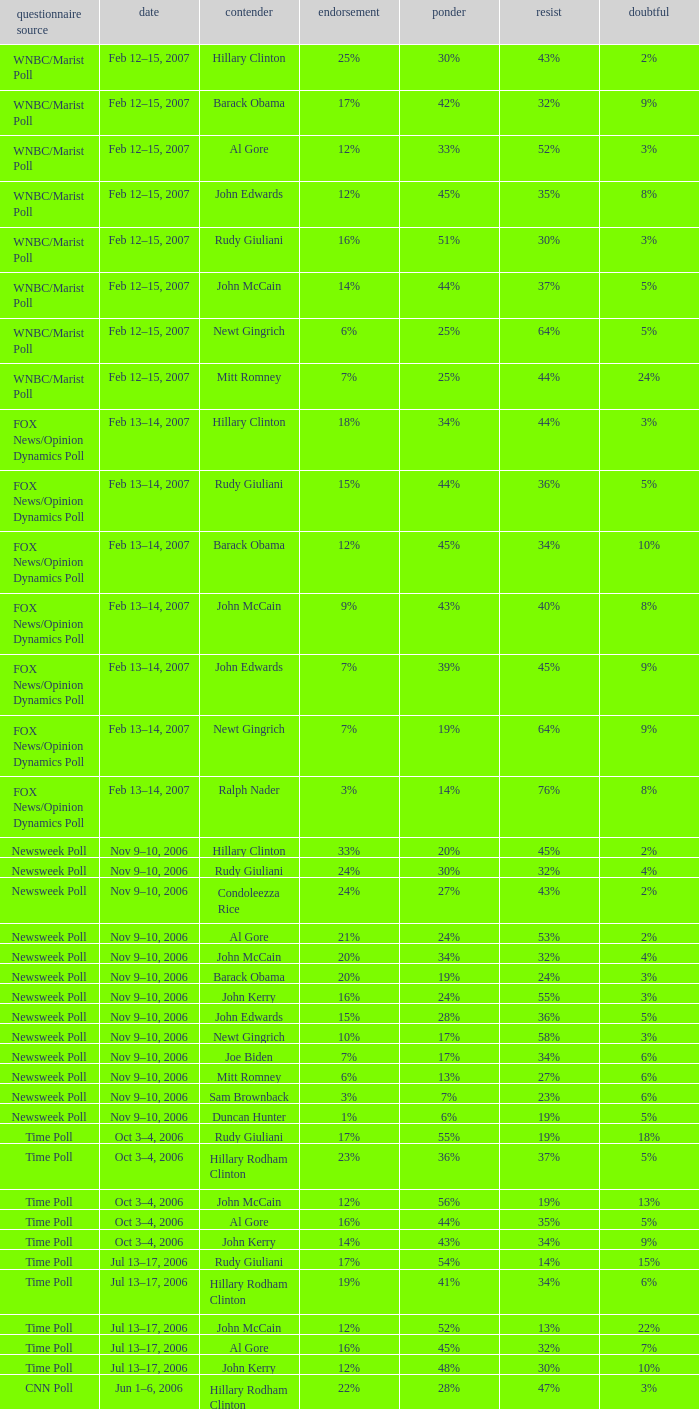Could you help me parse every detail presented in this table? {'header': ['questionnaire source', 'date', 'contender', 'endorsement', 'ponder', 'resist', 'doubtful'], 'rows': [['WNBC/Marist Poll', 'Feb 12–15, 2007', 'Hillary Clinton', '25%', '30%', '43%', '2%'], ['WNBC/Marist Poll', 'Feb 12–15, 2007', 'Barack Obama', '17%', '42%', '32%', '9%'], ['WNBC/Marist Poll', 'Feb 12–15, 2007', 'Al Gore', '12%', '33%', '52%', '3%'], ['WNBC/Marist Poll', 'Feb 12–15, 2007', 'John Edwards', '12%', '45%', '35%', '8%'], ['WNBC/Marist Poll', 'Feb 12–15, 2007', 'Rudy Giuliani', '16%', '51%', '30%', '3%'], ['WNBC/Marist Poll', 'Feb 12–15, 2007', 'John McCain', '14%', '44%', '37%', '5%'], ['WNBC/Marist Poll', 'Feb 12–15, 2007', 'Newt Gingrich', '6%', '25%', '64%', '5%'], ['WNBC/Marist Poll', 'Feb 12–15, 2007', 'Mitt Romney', '7%', '25%', '44%', '24%'], ['FOX News/Opinion Dynamics Poll', 'Feb 13–14, 2007', 'Hillary Clinton', '18%', '34%', '44%', '3%'], ['FOX News/Opinion Dynamics Poll', 'Feb 13–14, 2007', 'Rudy Giuliani', '15%', '44%', '36%', '5%'], ['FOX News/Opinion Dynamics Poll', 'Feb 13–14, 2007', 'Barack Obama', '12%', '45%', '34%', '10%'], ['FOX News/Opinion Dynamics Poll', 'Feb 13–14, 2007', 'John McCain', '9%', '43%', '40%', '8%'], ['FOX News/Opinion Dynamics Poll', 'Feb 13–14, 2007', 'John Edwards', '7%', '39%', '45%', '9%'], ['FOX News/Opinion Dynamics Poll', 'Feb 13–14, 2007', 'Newt Gingrich', '7%', '19%', '64%', '9%'], ['FOX News/Opinion Dynamics Poll', 'Feb 13–14, 2007', 'Ralph Nader', '3%', '14%', '76%', '8%'], ['Newsweek Poll', 'Nov 9–10, 2006', 'Hillary Clinton', '33%', '20%', '45%', '2%'], ['Newsweek Poll', 'Nov 9–10, 2006', 'Rudy Giuliani', '24%', '30%', '32%', '4%'], ['Newsweek Poll', 'Nov 9–10, 2006', 'Condoleezza Rice', '24%', '27%', '43%', '2%'], ['Newsweek Poll', 'Nov 9–10, 2006', 'Al Gore', '21%', '24%', '53%', '2%'], ['Newsweek Poll', 'Nov 9–10, 2006', 'John McCain', '20%', '34%', '32%', '4%'], ['Newsweek Poll', 'Nov 9–10, 2006', 'Barack Obama', '20%', '19%', '24%', '3%'], ['Newsweek Poll', 'Nov 9–10, 2006', 'John Kerry', '16%', '24%', '55%', '3%'], ['Newsweek Poll', 'Nov 9–10, 2006', 'John Edwards', '15%', '28%', '36%', '5%'], ['Newsweek Poll', 'Nov 9–10, 2006', 'Newt Gingrich', '10%', '17%', '58%', '3%'], ['Newsweek Poll', 'Nov 9–10, 2006', 'Joe Biden', '7%', '17%', '34%', '6%'], ['Newsweek Poll', 'Nov 9–10, 2006', 'Mitt Romney', '6%', '13%', '27%', '6%'], ['Newsweek Poll', 'Nov 9–10, 2006', 'Sam Brownback', '3%', '7%', '23%', '6%'], ['Newsweek Poll', 'Nov 9–10, 2006', 'Duncan Hunter', '1%', '6%', '19%', '5%'], ['Time Poll', 'Oct 3–4, 2006', 'Rudy Giuliani', '17%', '55%', '19%', '18%'], ['Time Poll', 'Oct 3–4, 2006', 'Hillary Rodham Clinton', '23%', '36%', '37%', '5%'], ['Time Poll', 'Oct 3–4, 2006', 'John McCain', '12%', '56%', '19%', '13%'], ['Time Poll', 'Oct 3–4, 2006', 'Al Gore', '16%', '44%', '35%', '5%'], ['Time Poll', 'Oct 3–4, 2006', 'John Kerry', '14%', '43%', '34%', '9%'], ['Time Poll', 'Jul 13–17, 2006', 'Rudy Giuliani', '17%', '54%', '14%', '15%'], ['Time Poll', 'Jul 13–17, 2006', 'Hillary Rodham Clinton', '19%', '41%', '34%', '6%'], ['Time Poll', 'Jul 13–17, 2006', 'John McCain', '12%', '52%', '13%', '22%'], ['Time Poll', 'Jul 13–17, 2006', 'Al Gore', '16%', '45%', '32%', '7%'], ['Time Poll', 'Jul 13–17, 2006', 'John Kerry', '12%', '48%', '30%', '10%'], ['CNN Poll', 'Jun 1–6, 2006', 'Hillary Rodham Clinton', '22%', '28%', '47%', '3%'], ['CNN Poll', 'Jun 1–6, 2006', 'Al Gore', '17%', '32%', '48%', '3%'], ['CNN Poll', 'Jun 1–6, 2006', 'John Kerry', '14%', '35%', '47%', '4%'], ['CNN Poll', 'Jun 1–6, 2006', 'Rudolph Giuliani', '19%', '45%', '30%', '6%'], ['CNN Poll', 'Jun 1–6, 2006', 'John McCain', '12%', '48%', '34%', '6%'], ['CNN Poll', 'Jun 1–6, 2006', 'Jeb Bush', '9%', '26%', '63%', '2%'], ['ABC News/Washington Post Poll', 'May 11–15, 2006', 'Hillary Clinton', '19%', '38%', '42%', '1%'], ['ABC News/Washington Post Poll', 'May 11–15, 2006', 'John McCain', '9%', '57%', '28%', '6%'], ['FOX News/Opinion Dynamics Poll', 'Feb 7–8, 2006', 'Hillary Clinton', '35%', '19%', '44%', '2%'], ['FOX News/Opinion Dynamics Poll', 'Feb 7–8, 2006', 'Rudy Giuliani', '33%', '38%', '24%', '6%'], ['FOX News/Opinion Dynamics Poll', 'Feb 7–8, 2006', 'John McCain', '30%', '40%', '22%', '7%'], ['FOX News/Opinion Dynamics Poll', 'Feb 7–8, 2006', 'John Kerry', '29%', '23%', '45%', '3%'], ['FOX News/Opinion Dynamics Poll', 'Feb 7–8, 2006', 'Condoleezza Rice', '14%', '38%', '46%', '3%'], ['CNN/USA Today/Gallup Poll', 'Jan 20–22, 2006', 'Hillary Rodham Clinton', '16%', '32%', '51%', '1%'], ['Diageo/Hotline Poll', 'Nov 11–15, 2005', 'John McCain', '23%', '46%', '15%', '15%'], ['CNN/USA Today/Gallup Poll', 'May 20–22, 2005', 'Hillary Rodham Clinton', '28%', '31%', '40%', '1%'], ['CNN/USA Today/Gallup Poll', 'Jun 9–10, 2003', 'Hillary Rodham Clinton', '20%', '33%', '45%', '2%']]} What percentage of people were opposed to the candidate based on the Time Poll poll that showed 6% of people were unsure? 34%. 